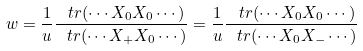Convert formula to latex. <formula><loc_0><loc_0><loc_500><loc_500>w = \frac { 1 } { u } \frac { \ t r ( \cdots X _ { 0 } X _ { 0 } \cdots ) } { \ t r ( \cdots X _ { + } X _ { 0 } \cdots ) } = \frac { 1 } { u } \frac { \ t r ( \cdots X _ { 0 } X _ { 0 } \cdots ) } { \ t r ( \cdots X _ { 0 } X _ { - } \cdots ) }</formula> 